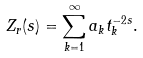<formula> <loc_0><loc_0><loc_500><loc_500>Z _ { r } ( s ) = \sum _ { k = 1 } ^ { \infty } a _ { k } t _ { k } ^ { - 2 s } .</formula> 